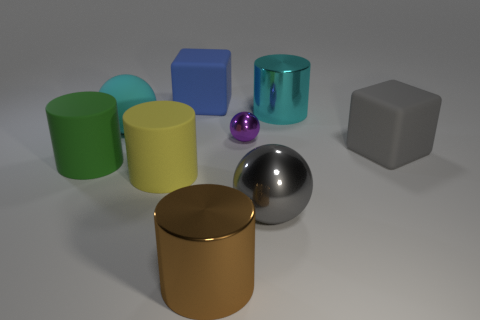Are there an equal number of blue rubber things right of the cyan rubber thing and blue rubber cubes to the right of the brown metal thing?
Your response must be concise. No. How many other things are made of the same material as the large blue block?
Provide a succinct answer. 4. Is the number of gray metallic things that are to the right of the cyan cylinder the same as the number of large gray cubes?
Offer a terse response. No. There is a yellow matte object; is it the same size as the blue rubber thing to the left of the large cyan metallic cylinder?
Make the answer very short. Yes. There is a rubber thing that is left of the cyan rubber ball; what shape is it?
Provide a succinct answer. Cylinder. Is there any other thing that has the same shape as the small purple metallic thing?
Offer a terse response. Yes. Are there any cylinders?
Give a very brief answer. Yes. Do the cylinder that is on the left side of the big yellow matte cylinder and the block in front of the tiny shiny thing have the same size?
Give a very brief answer. Yes. The object that is both behind the rubber ball and in front of the big blue matte object is made of what material?
Provide a short and direct response. Metal. There is a small metallic ball; what number of large shiny cylinders are behind it?
Keep it short and to the point. 1. 